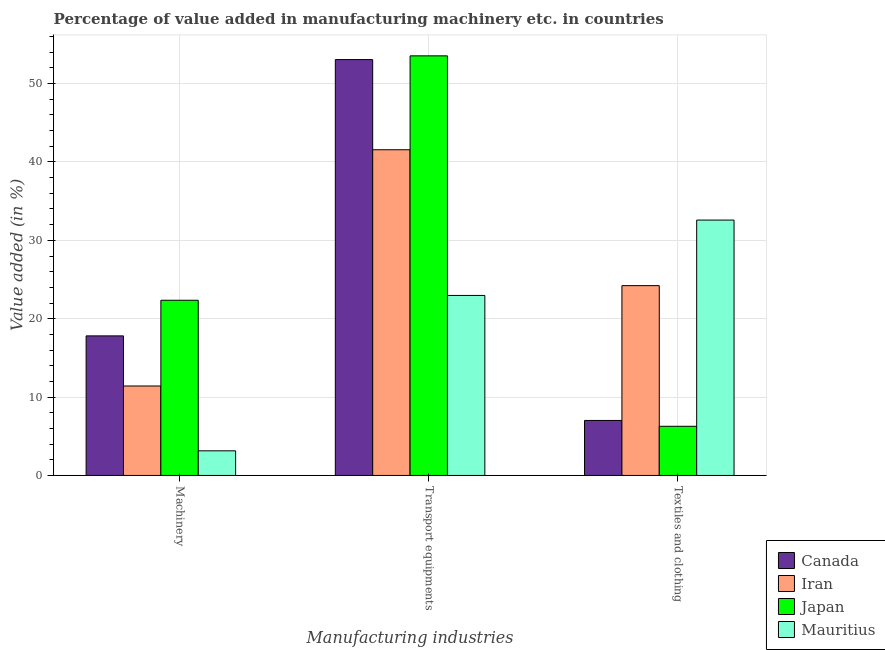How many groups of bars are there?
Give a very brief answer. 3. How many bars are there on the 2nd tick from the left?
Keep it short and to the point. 4. How many bars are there on the 2nd tick from the right?
Make the answer very short. 4. What is the label of the 3rd group of bars from the left?
Your response must be concise. Textiles and clothing. What is the value added in manufacturing textile and clothing in Japan?
Your answer should be compact. 6.27. Across all countries, what is the maximum value added in manufacturing machinery?
Offer a terse response. 22.35. Across all countries, what is the minimum value added in manufacturing textile and clothing?
Give a very brief answer. 6.27. In which country was the value added in manufacturing transport equipments maximum?
Your answer should be very brief. Japan. In which country was the value added in manufacturing transport equipments minimum?
Offer a terse response. Mauritius. What is the total value added in manufacturing machinery in the graph?
Your answer should be compact. 54.72. What is the difference between the value added in manufacturing machinery in Iran and that in Canada?
Ensure brevity in your answer.  -6.39. What is the difference between the value added in manufacturing textile and clothing in Mauritius and the value added in manufacturing machinery in Iran?
Keep it short and to the point. 21.17. What is the average value added in manufacturing textile and clothing per country?
Your answer should be very brief. 17.52. What is the difference between the value added in manufacturing textile and clothing and value added in manufacturing machinery in Japan?
Provide a short and direct response. -16.08. What is the ratio of the value added in manufacturing machinery in Iran to that in Japan?
Keep it short and to the point. 0.51. What is the difference between the highest and the second highest value added in manufacturing textile and clothing?
Provide a short and direct response. 8.37. What is the difference between the highest and the lowest value added in manufacturing transport equipments?
Your answer should be compact. 30.57. In how many countries, is the value added in manufacturing machinery greater than the average value added in manufacturing machinery taken over all countries?
Offer a very short reply. 2. Is it the case that in every country, the sum of the value added in manufacturing machinery and value added in manufacturing transport equipments is greater than the value added in manufacturing textile and clothing?
Make the answer very short. No. How many countries are there in the graph?
Provide a succinct answer. 4. Does the graph contain any zero values?
Your response must be concise. No. Where does the legend appear in the graph?
Give a very brief answer. Bottom right. What is the title of the graph?
Offer a very short reply. Percentage of value added in manufacturing machinery etc. in countries. Does "Congo (Democratic)" appear as one of the legend labels in the graph?
Offer a terse response. No. What is the label or title of the X-axis?
Ensure brevity in your answer.  Manufacturing industries. What is the label or title of the Y-axis?
Provide a succinct answer. Value added (in %). What is the Value added (in %) of Canada in Machinery?
Offer a terse response. 17.81. What is the Value added (in %) of Iran in Machinery?
Provide a succinct answer. 11.42. What is the Value added (in %) of Japan in Machinery?
Your response must be concise. 22.35. What is the Value added (in %) in Mauritius in Machinery?
Offer a terse response. 3.14. What is the Value added (in %) of Canada in Transport equipments?
Your answer should be very brief. 53.06. What is the Value added (in %) in Iran in Transport equipments?
Give a very brief answer. 41.56. What is the Value added (in %) of Japan in Transport equipments?
Your answer should be compact. 53.54. What is the Value added (in %) in Mauritius in Transport equipments?
Offer a terse response. 22.97. What is the Value added (in %) in Canada in Textiles and clothing?
Make the answer very short. 7.02. What is the Value added (in %) in Iran in Textiles and clothing?
Give a very brief answer. 24.22. What is the Value added (in %) of Japan in Textiles and clothing?
Make the answer very short. 6.27. What is the Value added (in %) of Mauritius in Textiles and clothing?
Provide a short and direct response. 32.59. Across all Manufacturing industries, what is the maximum Value added (in %) in Canada?
Give a very brief answer. 53.06. Across all Manufacturing industries, what is the maximum Value added (in %) in Iran?
Ensure brevity in your answer.  41.56. Across all Manufacturing industries, what is the maximum Value added (in %) in Japan?
Give a very brief answer. 53.54. Across all Manufacturing industries, what is the maximum Value added (in %) of Mauritius?
Provide a short and direct response. 32.59. Across all Manufacturing industries, what is the minimum Value added (in %) in Canada?
Make the answer very short. 7.02. Across all Manufacturing industries, what is the minimum Value added (in %) in Iran?
Provide a short and direct response. 11.42. Across all Manufacturing industries, what is the minimum Value added (in %) of Japan?
Your answer should be compact. 6.27. Across all Manufacturing industries, what is the minimum Value added (in %) of Mauritius?
Provide a short and direct response. 3.14. What is the total Value added (in %) in Canada in the graph?
Provide a succinct answer. 77.89. What is the total Value added (in %) of Iran in the graph?
Make the answer very short. 77.2. What is the total Value added (in %) of Japan in the graph?
Provide a short and direct response. 82.17. What is the total Value added (in %) in Mauritius in the graph?
Keep it short and to the point. 58.7. What is the difference between the Value added (in %) of Canada in Machinery and that in Transport equipments?
Ensure brevity in your answer.  -35.26. What is the difference between the Value added (in %) of Iran in Machinery and that in Transport equipments?
Make the answer very short. -30.15. What is the difference between the Value added (in %) in Japan in Machinery and that in Transport equipments?
Keep it short and to the point. -31.19. What is the difference between the Value added (in %) of Mauritius in Machinery and that in Transport equipments?
Provide a short and direct response. -19.83. What is the difference between the Value added (in %) of Canada in Machinery and that in Textiles and clothing?
Keep it short and to the point. 10.79. What is the difference between the Value added (in %) of Iran in Machinery and that in Textiles and clothing?
Provide a succinct answer. -12.81. What is the difference between the Value added (in %) in Japan in Machinery and that in Textiles and clothing?
Keep it short and to the point. 16.08. What is the difference between the Value added (in %) of Mauritius in Machinery and that in Textiles and clothing?
Provide a short and direct response. -29.45. What is the difference between the Value added (in %) in Canada in Transport equipments and that in Textiles and clothing?
Provide a short and direct response. 46.05. What is the difference between the Value added (in %) in Iran in Transport equipments and that in Textiles and clothing?
Keep it short and to the point. 17.34. What is the difference between the Value added (in %) of Japan in Transport equipments and that in Textiles and clothing?
Give a very brief answer. 47.27. What is the difference between the Value added (in %) in Mauritius in Transport equipments and that in Textiles and clothing?
Provide a succinct answer. -9.62. What is the difference between the Value added (in %) of Canada in Machinery and the Value added (in %) of Iran in Transport equipments?
Your response must be concise. -23.75. What is the difference between the Value added (in %) of Canada in Machinery and the Value added (in %) of Japan in Transport equipments?
Offer a terse response. -35.73. What is the difference between the Value added (in %) of Canada in Machinery and the Value added (in %) of Mauritius in Transport equipments?
Your answer should be very brief. -5.16. What is the difference between the Value added (in %) in Iran in Machinery and the Value added (in %) in Japan in Transport equipments?
Your answer should be very brief. -42.13. What is the difference between the Value added (in %) in Iran in Machinery and the Value added (in %) in Mauritius in Transport equipments?
Your answer should be very brief. -11.55. What is the difference between the Value added (in %) in Japan in Machinery and the Value added (in %) in Mauritius in Transport equipments?
Your answer should be very brief. -0.61. What is the difference between the Value added (in %) of Canada in Machinery and the Value added (in %) of Iran in Textiles and clothing?
Your answer should be very brief. -6.41. What is the difference between the Value added (in %) in Canada in Machinery and the Value added (in %) in Japan in Textiles and clothing?
Provide a short and direct response. 11.53. What is the difference between the Value added (in %) of Canada in Machinery and the Value added (in %) of Mauritius in Textiles and clothing?
Your answer should be very brief. -14.78. What is the difference between the Value added (in %) in Iran in Machinery and the Value added (in %) in Japan in Textiles and clothing?
Give a very brief answer. 5.14. What is the difference between the Value added (in %) of Iran in Machinery and the Value added (in %) of Mauritius in Textiles and clothing?
Offer a terse response. -21.17. What is the difference between the Value added (in %) in Japan in Machinery and the Value added (in %) in Mauritius in Textiles and clothing?
Your answer should be very brief. -10.23. What is the difference between the Value added (in %) of Canada in Transport equipments and the Value added (in %) of Iran in Textiles and clothing?
Offer a very short reply. 28.84. What is the difference between the Value added (in %) of Canada in Transport equipments and the Value added (in %) of Japan in Textiles and clothing?
Give a very brief answer. 46.79. What is the difference between the Value added (in %) in Canada in Transport equipments and the Value added (in %) in Mauritius in Textiles and clothing?
Give a very brief answer. 20.48. What is the difference between the Value added (in %) in Iran in Transport equipments and the Value added (in %) in Japan in Textiles and clothing?
Your answer should be compact. 35.29. What is the difference between the Value added (in %) in Iran in Transport equipments and the Value added (in %) in Mauritius in Textiles and clothing?
Your answer should be compact. 8.97. What is the difference between the Value added (in %) in Japan in Transport equipments and the Value added (in %) in Mauritius in Textiles and clothing?
Provide a short and direct response. 20.95. What is the average Value added (in %) in Canada per Manufacturing industries?
Make the answer very short. 25.96. What is the average Value added (in %) of Iran per Manufacturing industries?
Provide a succinct answer. 25.73. What is the average Value added (in %) in Japan per Manufacturing industries?
Your answer should be compact. 27.39. What is the average Value added (in %) of Mauritius per Manufacturing industries?
Keep it short and to the point. 19.57. What is the difference between the Value added (in %) in Canada and Value added (in %) in Iran in Machinery?
Give a very brief answer. 6.39. What is the difference between the Value added (in %) in Canada and Value added (in %) in Japan in Machinery?
Give a very brief answer. -4.55. What is the difference between the Value added (in %) in Canada and Value added (in %) in Mauritius in Machinery?
Your answer should be very brief. 14.67. What is the difference between the Value added (in %) of Iran and Value added (in %) of Japan in Machinery?
Provide a short and direct response. -10.94. What is the difference between the Value added (in %) in Iran and Value added (in %) in Mauritius in Machinery?
Make the answer very short. 8.27. What is the difference between the Value added (in %) in Japan and Value added (in %) in Mauritius in Machinery?
Your response must be concise. 19.21. What is the difference between the Value added (in %) of Canada and Value added (in %) of Iran in Transport equipments?
Provide a short and direct response. 11.5. What is the difference between the Value added (in %) in Canada and Value added (in %) in Japan in Transport equipments?
Provide a succinct answer. -0.48. What is the difference between the Value added (in %) of Canada and Value added (in %) of Mauritius in Transport equipments?
Ensure brevity in your answer.  30.1. What is the difference between the Value added (in %) of Iran and Value added (in %) of Japan in Transport equipments?
Your answer should be very brief. -11.98. What is the difference between the Value added (in %) of Iran and Value added (in %) of Mauritius in Transport equipments?
Keep it short and to the point. 18.59. What is the difference between the Value added (in %) of Japan and Value added (in %) of Mauritius in Transport equipments?
Offer a terse response. 30.57. What is the difference between the Value added (in %) in Canada and Value added (in %) in Iran in Textiles and clothing?
Offer a terse response. -17.2. What is the difference between the Value added (in %) of Canada and Value added (in %) of Japan in Textiles and clothing?
Offer a very short reply. 0.75. What is the difference between the Value added (in %) of Canada and Value added (in %) of Mauritius in Textiles and clothing?
Your answer should be compact. -25.57. What is the difference between the Value added (in %) in Iran and Value added (in %) in Japan in Textiles and clothing?
Your answer should be very brief. 17.95. What is the difference between the Value added (in %) in Iran and Value added (in %) in Mauritius in Textiles and clothing?
Offer a very short reply. -8.37. What is the difference between the Value added (in %) in Japan and Value added (in %) in Mauritius in Textiles and clothing?
Provide a short and direct response. -26.31. What is the ratio of the Value added (in %) of Canada in Machinery to that in Transport equipments?
Make the answer very short. 0.34. What is the ratio of the Value added (in %) of Iran in Machinery to that in Transport equipments?
Provide a succinct answer. 0.27. What is the ratio of the Value added (in %) of Japan in Machinery to that in Transport equipments?
Ensure brevity in your answer.  0.42. What is the ratio of the Value added (in %) of Mauritius in Machinery to that in Transport equipments?
Provide a short and direct response. 0.14. What is the ratio of the Value added (in %) in Canada in Machinery to that in Textiles and clothing?
Your answer should be very brief. 2.54. What is the ratio of the Value added (in %) of Iran in Machinery to that in Textiles and clothing?
Keep it short and to the point. 0.47. What is the ratio of the Value added (in %) of Japan in Machinery to that in Textiles and clothing?
Your answer should be very brief. 3.56. What is the ratio of the Value added (in %) in Mauritius in Machinery to that in Textiles and clothing?
Your response must be concise. 0.1. What is the ratio of the Value added (in %) in Canada in Transport equipments to that in Textiles and clothing?
Provide a succinct answer. 7.56. What is the ratio of the Value added (in %) of Iran in Transport equipments to that in Textiles and clothing?
Offer a terse response. 1.72. What is the ratio of the Value added (in %) in Japan in Transport equipments to that in Textiles and clothing?
Keep it short and to the point. 8.54. What is the ratio of the Value added (in %) in Mauritius in Transport equipments to that in Textiles and clothing?
Make the answer very short. 0.7. What is the difference between the highest and the second highest Value added (in %) in Canada?
Your answer should be compact. 35.26. What is the difference between the highest and the second highest Value added (in %) in Iran?
Make the answer very short. 17.34. What is the difference between the highest and the second highest Value added (in %) of Japan?
Provide a succinct answer. 31.19. What is the difference between the highest and the second highest Value added (in %) in Mauritius?
Ensure brevity in your answer.  9.62. What is the difference between the highest and the lowest Value added (in %) of Canada?
Your answer should be compact. 46.05. What is the difference between the highest and the lowest Value added (in %) in Iran?
Keep it short and to the point. 30.15. What is the difference between the highest and the lowest Value added (in %) of Japan?
Make the answer very short. 47.27. What is the difference between the highest and the lowest Value added (in %) of Mauritius?
Offer a very short reply. 29.45. 